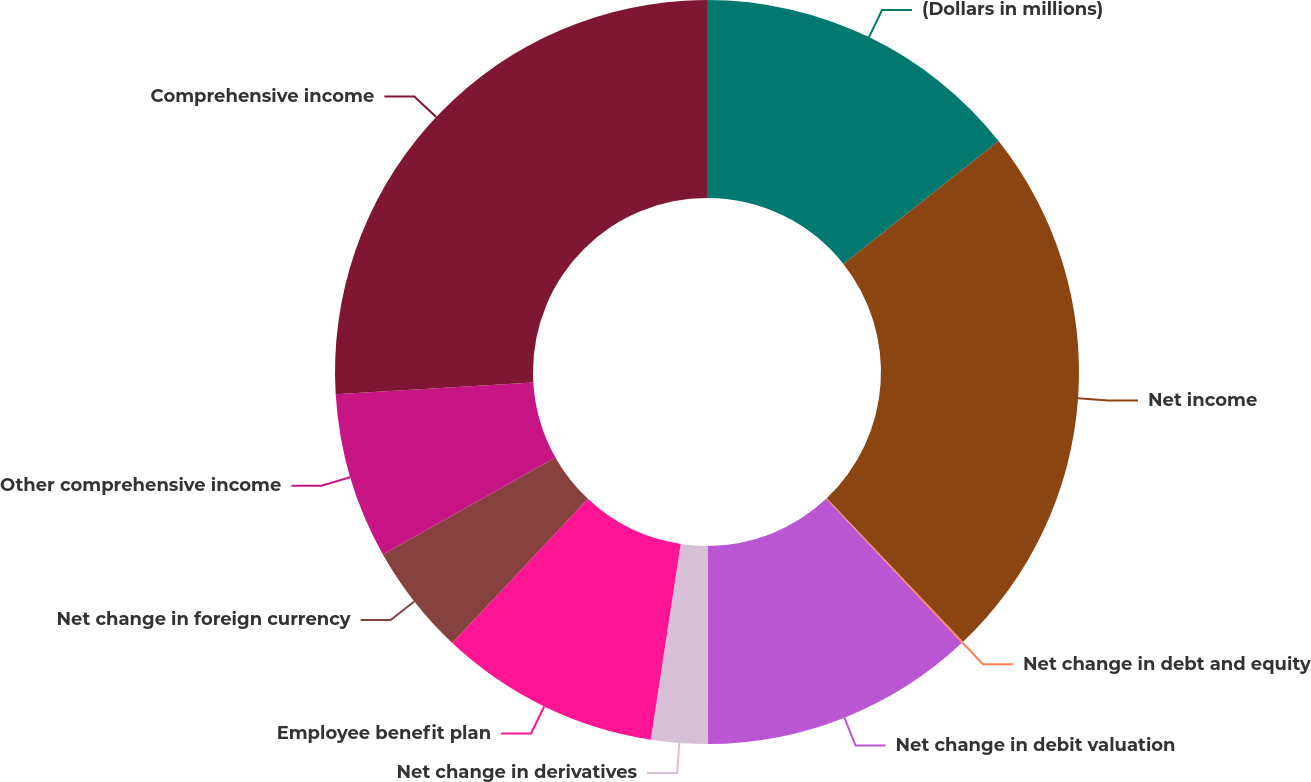Convert chart to OTSL. <chart><loc_0><loc_0><loc_500><loc_500><pie_chart><fcel>(Dollars in millions)<fcel>Net income<fcel>Net change in debt and equity<fcel>Net change in debit valuation<fcel>Net change in derivatives<fcel>Employee benefit plan<fcel>Net change in foreign currency<fcel>Other comprehensive income<fcel>Comprehensive income<nl><fcel>14.34%<fcel>23.58%<fcel>0.08%<fcel>11.96%<fcel>2.46%<fcel>9.59%<fcel>4.83%<fcel>7.21%<fcel>25.96%<nl></chart> 